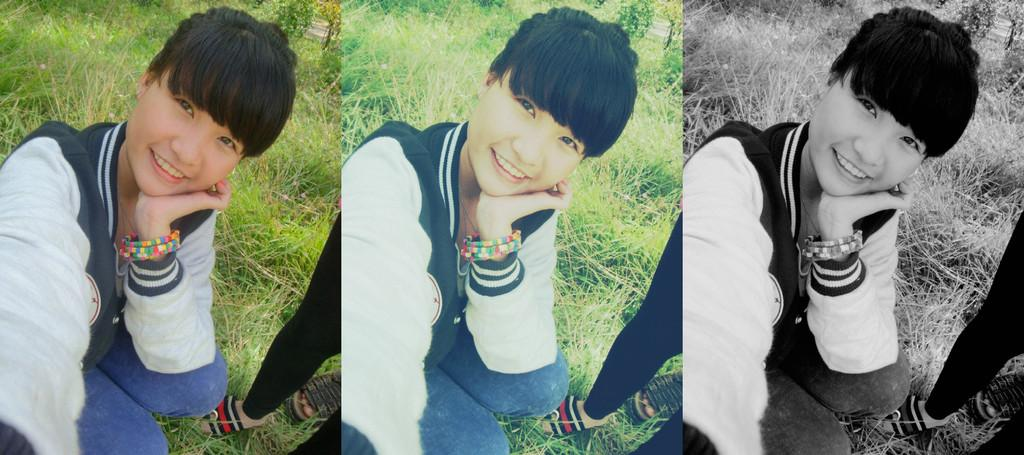What is the style of the image? The image is a collage with different filters. What are the people in the image doing? There is a person in a squat position and another person standing. What type of terrain is visible behind the people? The grass is visible behind the people. What type of toothbrush is being used in the image? There is no toothbrush present in the image. What is the topic of the discussion between the two people in the image? The image does not depict a discussion between the two people; it only shows them in different positions. 